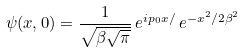<formula> <loc_0><loc_0><loc_500><loc_500>\psi ( x , 0 ) = \frac { 1 } { \sqrt { \beta \sqrt { \pi } } } \, e ^ { i p _ { 0 } x / } \, e ^ { - x ^ { 2 } / 2 \beta ^ { 2 } }</formula> 